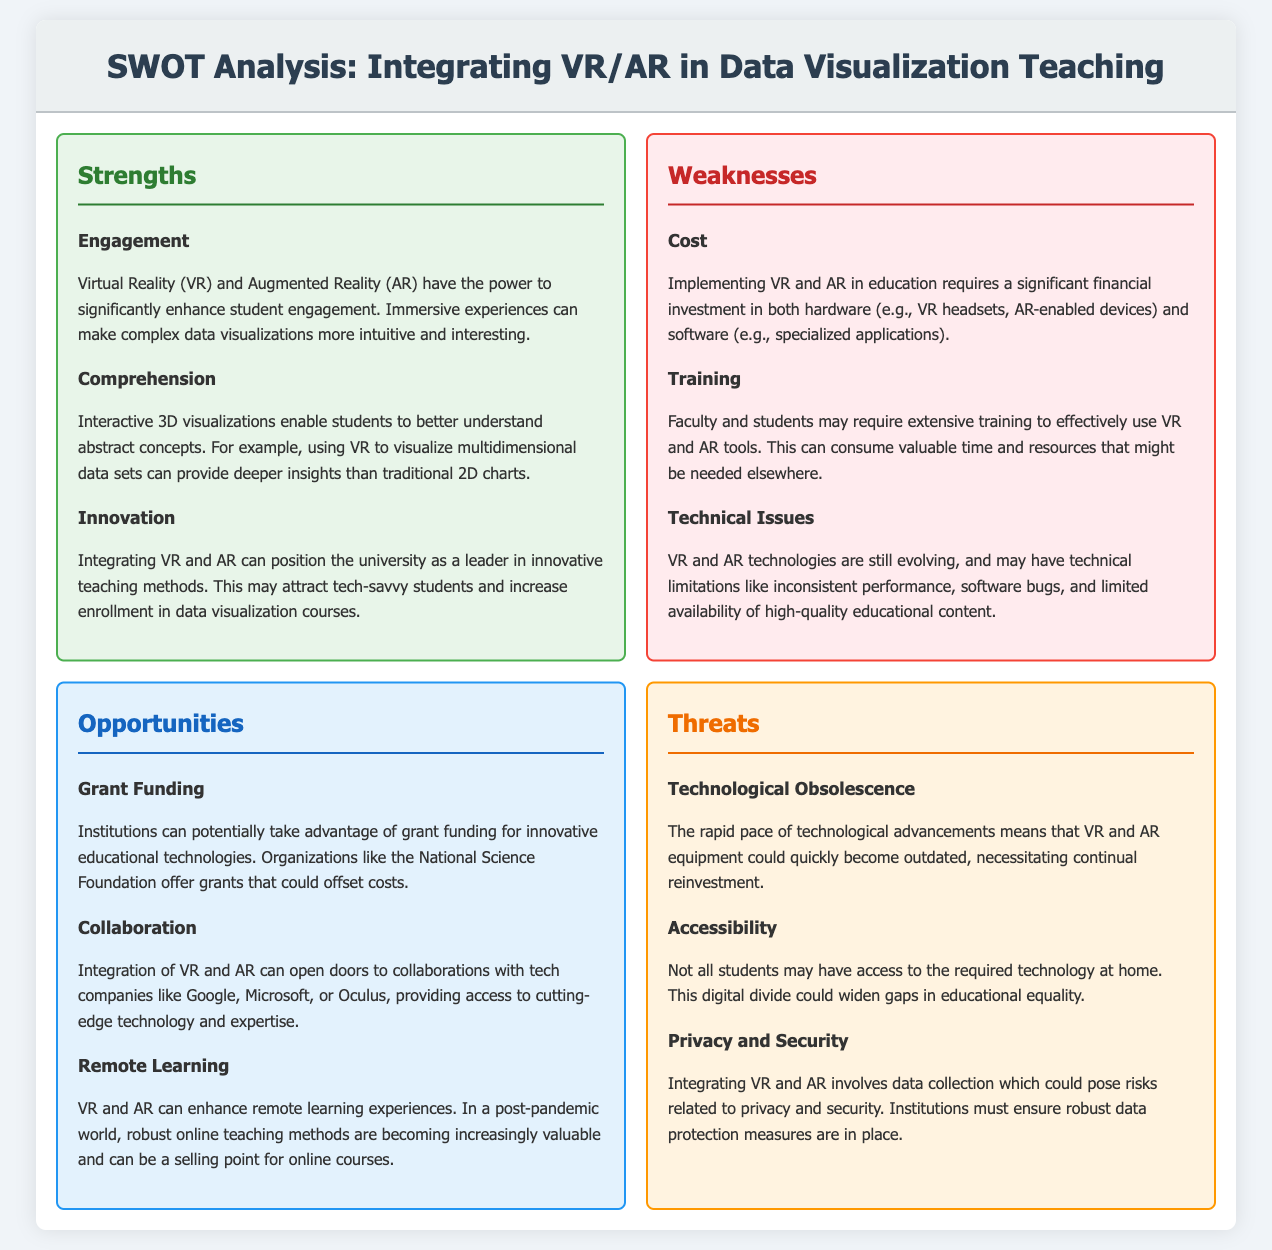What is one strength of integrating VR and AR in data visualization teaching? One strength mentioned in the document is that VR and AR significantly enhance student engagement by making complex data visualizations more intuitive and interesting.
Answer: Engagement What is a weakness related to the cost of implementing VR and AR in education? The document states that implementing VR and AR in education requires a significant financial investment in hardware and software.
Answer: Cost Which opportunity involves financial aid for technology integration in education? The document highlights the potential for institutions to take advantage of grant funding for innovative educational technologies.
Answer: Grant Funding What threat is associated with the rapid pace of technological advancements? The document notes that the rapid pace of technological advancements means that VR and AR equipment could quickly become outdated.
Answer: Technological Obsolescence How many strengths are listed in the document? The document lists three strengths associated with integrating VR and AR in teaching methods.
Answer: 3 What could the integration of VR and AR potentially attract to universities according to the document? The document suggests that innovative teaching methods could attract tech-savvy students and increase enrollment in data visualization courses.
Answer: Tech-savvy students What is a technical limitation mentioned as a weakness? The document includes that inconsistencies in performance and software bugs can hinder the effectiveness of VR and AR tools.
Answer: Technical Issues What is one potential benefit of VR and AR for remote learning? The document indicates that VR and AR can enhance remote learning experiences, which are increasingly valuable post-pandemic.
Answer: Remote Learning 